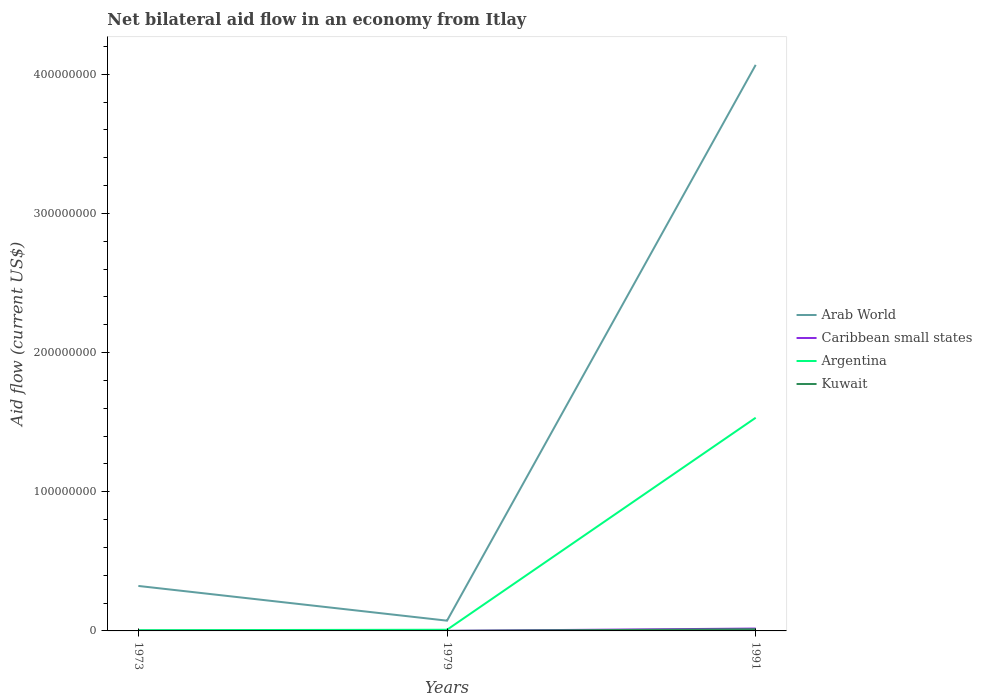How many different coloured lines are there?
Provide a succinct answer. 4. Is the number of lines equal to the number of legend labels?
Keep it short and to the point. Yes. Across all years, what is the maximum net bilateral aid flow in Argentina?
Offer a very short reply. 5.30e+05. What is the total net bilateral aid flow in Caribbean small states in the graph?
Provide a succinct answer. -1.65e+06. What is the difference between the highest and the second highest net bilateral aid flow in Kuwait?
Provide a succinct answer. 1.18e+06. How many lines are there?
Offer a very short reply. 4. How many years are there in the graph?
Your response must be concise. 3. Are the values on the major ticks of Y-axis written in scientific E-notation?
Your answer should be compact. No. Does the graph contain any zero values?
Your response must be concise. No. How many legend labels are there?
Ensure brevity in your answer.  4. What is the title of the graph?
Provide a short and direct response. Net bilateral aid flow in an economy from Itlay. Does "Virgin Islands" appear as one of the legend labels in the graph?
Provide a short and direct response. No. What is the label or title of the X-axis?
Provide a succinct answer. Years. What is the label or title of the Y-axis?
Give a very brief answer. Aid flow (current US$). What is the Aid flow (current US$) in Arab World in 1973?
Ensure brevity in your answer.  3.23e+07. What is the Aid flow (current US$) of Caribbean small states in 1973?
Offer a very short reply. 6.00e+04. What is the Aid flow (current US$) in Argentina in 1973?
Provide a short and direct response. 5.30e+05. What is the Aid flow (current US$) of Kuwait in 1973?
Give a very brief answer. 5.00e+04. What is the Aid flow (current US$) in Arab World in 1979?
Provide a short and direct response. 7.37e+06. What is the Aid flow (current US$) in Caribbean small states in 1979?
Keep it short and to the point. 5.00e+04. What is the Aid flow (current US$) of Argentina in 1979?
Your answer should be very brief. 8.40e+05. What is the Aid flow (current US$) of Arab World in 1991?
Offer a very short reply. 4.07e+08. What is the Aid flow (current US$) in Caribbean small states in 1991?
Keep it short and to the point. 1.71e+06. What is the Aid flow (current US$) in Argentina in 1991?
Your answer should be very brief. 1.53e+08. What is the Aid flow (current US$) in Kuwait in 1991?
Provide a short and direct response. 1.19e+06. Across all years, what is the maximum Aid flow (current US$) in Arab World?
Your answer should be very brief. 4.07e+08. Across all years, what is the maximum Aid flow (current US$) of Caribbean small states?
Ensure brevity in your answer.  1.71e+06. Across all years, what is the maximum Aid flow (current US$) of Argentina?
Give a very brief answer. 1.53e+08. Across all years, what is the maximum Aid flow (current US$) in Kuwait?
Your response must be concise. 1.19e+06. Across all years, what is the minimum Aid flow (current US$) in Arab World?
Give a very brief answer. 7.37e+06. Across all years, what is the minimum Aid flow (current US$) in Argentina?
Provide a short and direct response. 5.30e+05. Across all years, what is the minimum Aid flow (current US$) in Kuwait?
Your answer should be compact. 10000. What is the total Aid flow (current US$) of Arab World in the graph?
Your answer should be very brief. 4.46e+08. What is the total Aid flow (current US$) of Caribbean small states in the graph?
Provide a succinct answer. 1.82e+06. What is the total Aid flow (current US$) of Argentina in the graph?
Ensure brevity in your answer.  1.55e+08. What is the total Aid flow (current US$) in Kuwait in the graph?
Your answer should be very brief. 1.25e+06. What is the difference between the Aid flow (current US$) of Arab World in 1973 and that in 1979?
Your response must be concise. 2.50e+07. What is the difference between the Aid flow (current US$) in Caribbean small states in 1973 and that in 1979?
Provide a succinct answer. 10000. What is the difference between the Aid flow (current US$) of Argentina in 1973 and that in 1979?
Your response must be concise. -3.10e+05. What is the difference between the Aid flow (current US$) of Arab World in 1973 and that in 1991?
Provide a short and direct response. -3.74e+08. What is the difference between the Aid flow (current US$) of Caribbean small states in 1973 and that in 1991?
Provide a short and direct response. -1.65e+06. What is the difference between the Aid flow (current US$) in Argentina in 1973 and that in 1991?
Provide a short and direct response. -1.53e+08. What is the difference between the Aid flow (current US$) of Kuwait in 1973 and that in 1991?
Give a very brief answer. -1.14e+06. What is the difference between the Aid flow (current US$) of Arab World in 1979 and that in 1991?
Your answer should be compact. -3.99e+08. What is the difference between the Aid flow (current US$) in Caribbean small states in 1979 and that in 1991?
Provide a short and direct response. -1.66e+06. What is the difference between the Aid flow (current US$) in Argentina in 1979 and that in 1991?
Provide a short and direct response. -1.52e+08. What is the difference between the Aid flow (current US$) of Kuwait in 1979 and that in 1991?
Offer a very short reply. -1.18e+06. What is the difference between the Aid flow (current US$) of Arab World in 1973 and the Aid flow (current US$) of Caribbean small states in 1979?
Provide a succinct answer. 3.23e+07. What is the difference between the Aid flow (current US$) of Arab World in 1973 and the Aid flow (current US$) of Argentina in 1979?
Your answer should be compact. 3.15e+07. What is the difference between the Aid flow (current US$) in Arab World in 1973 and the Aid flow (current US$) in Kuwait in 1979?
Keep it short and to the point. 3.23e+07. What is the difference between the Aid flow (current US$) in Caribbean small states in 1973 and the Aid flow (current US$) in Argentina in 1979?
Make the answer very short. -7.80e+05. What is the difference between the Aid flow (current US$) of Argentina in 1973 and the Aid flow (current US$) of Kuwait in 1979?
Provide a short and direct response. 5.20e+05. What is the difference between the Aid flow (current US$) of Arab World in 1973 and the Aid flow (current US$) of Caribbean small states in 1991?
Provide a short and direct response. 3.06e+07. What is the difference between the Aid flow (current US$) of Arab World in 1973 and the Aid flow (current US$) of Argentina in 1991?
Your answer should be very brief. -1.21e+08. What is the difference between the Aid flow (current US$) of Arab World in 1973 and the Aid flow (current US$) of Kuwait in 1991?
Offer a terse response. 3.11e+07. What is the difference between the Aid flow (current US$) in Caribbean small states in 1973 and the Aid flow (current US$) in Argentina in 1991?
Keep it short and to the point. -1.53e+08. What is the difference between the Aid flow (current US$) of Caribbean small states in 1973 and the Aid flow (current US$) of Kuwait in 1991?
Make the answer very short. -1.13e+06. What is the difference between the Aid flow (current US$) in Argentina in 1973 and the Aid flow (current US$) in Kuwait in 1991?
Make the answer very short. -6.60e+05. What is the difference between the Aid flow (current US$) of Arab World in 1979 and the Aid flow (current US$) of Caribbean small states in 1991?
Offer a very short reply. 5.66e+06. What is the difference between the Aid flow (current US$) of Arab World in 1979 and the Aid flow (current US$) of Argentina in 1991?
Keep it short and to the point. -1.46e+08. What is the difference between the Aid flow (current US$) in Arab World in 1979 and the Aid flow (current US$) in Kuwait in 1991?
Give a very brief answer. 6.18e+06. What is the difference between the Aid flow (current US$) of Caribbean small states in 1979 and the Aid flow (current US$) of Argentina in 1991?
Your response must be concise. -1.53e+08. What is the difference between the Aid flow (current US$) in Caribbean small states in 1979 and the Aid flow (current US$) in Kuwait in 1991?
Provide a succinct answer. -1.14e+06. What is the difference between the Aid flow (current US$) in Argentina in 1979 and the Aid flow (current US$) in Kuwait in 1991?
Give a very brief answer. -3.50e+05. What is the average Aid flow (current US$) of Arab World per year?
Provide a short and direct response. 1.49e+08. What is the average Aid flow (current US$) in Caribbean small states per year?
Keep it short and to the point. 6.07e+05. What is the average Aid flow (current US$) of Argentina per year?
Provide a short and direct response. 5.15e+07. What is the average Aid flow (current US$) in Kuwait per year?
Ensure brevity in your answer.  4.17e+05. In the year 1973, what is the difference between the Aid flow (current US$) in Arab World and Aid flow (current US$) in Caribbean small states?
Offer a terse response. 3.23e+07. In the year 1973, what is the difference between the Aid flow (current US$) of Arab World and Aid flow (current US$) of Argentina?
Ensure brevity in your answer.  3.18e+07. In the year 1973, what is the difference between the Aid flow (current US$) in Arab World and Aid flow (current US$) in Kuwait?
Keep it short and to the point. 3.23e+07. In the year 1973, what is the difference between the Aid flow (current US$) of Caribbean small states and Aid flow (current US$) of Argentina?
Ensure brevity in your answer.  -4.70e+05. In the year 1973, what is the difference between the Aid flow (current US$) of Caribbean small states and Aid flow (current US$) of Kuwait?
Offer a very short reply. 10000. In the year 1973, what is the difference between the Aid flow (current US$) of Argentina and Aid flow (current US$) of Kuwait?
Your answer should be compact. 4.80e+05. In the year 1979, what is the difference between the Aid flow (current US$) in Arab World and Aid flow (current US$) in Caribbean small states?
Offer a very short reply. 7.32e+06. In the year 1979, what is the difference between the Aid flow (current US$) of Arab World and Aid flow (current US$) of Argentina?
Your response must be concise. 6.53e+06. In the year 1979, what is the difference between the Aid flow (current US$) in Arab World and Aid flow (current US$) in Kuwait?
Provide a succinct answer. 7.36e+06. In the year 1979, what is the difference between the Aid flow (current US$) in Caribbean small states and Aid flow (current US$) in Argentina?
Your answer should be very brief. -7.90e+05. In the year 1979, what is the difference between the Aid flow (current US$) in Caribbean small states and Aid flow (current US$) in Kuwait?
Make the answer very short. 4.00e+04. In the year 1979, what is the difference between the Aid flow (current US$) of Argentina and Aid flow (current US$) of Kuwait?
Provide a short and direct response. 8.30e+05. In the year 1991, what is the difference between the Aid flow (current US$) of Arab World and Aid flow (current US$) of Caribbean small states?
Make the answer very short. 4.05e+08. In the year 1991, what is the difference between the Aid flow (current US$) in Arab World and Aid flow (current US$) in Argentina?
Your answer should be compact. 2.54e+08. In the year 1991, what is the difference between the Aid flow (current US$) of Arab World and Aid flow (current US$) of Kuwait?
Your answer should be very brief. 4.06e+08. In the year 1991, what is the difference between the Aid flow (current US$) of Caribbean small states and Aid flow (current US$) of Argentina?
Give a very brief answer. -1.51e+08. In the year 1991, what is the difference between the Aid flow (current US$) of Caribbean small states and Aid flow (current US$) of Kuwait?
Your response must be concise. 5.20e+05. In the year 1991, what is the difference between the Aid flow (current US$) in Argentina and Aid flow (current US$) in Kuwait?
Provide a short and direct response. 1.52e+08. What is the ratio of the Aid flow (current US$) in Arab World in 1973 to that in 1979?
Keep it short and to the point. 4.39. What is the ratio of the Aid flow (current US$) in Caribbean small states in 1973 to that in 1979?
Provide a succinct answer. 1.2. What is the ratio of the Aid flow (current US$) of Argentina in 1973 to that in 1979?
Offer a terse response. 0.63. What is the ratio of the Aid flow (current US$) of Arab World in 1973 to that in 1991?
Your answer should be compact. 0.08. What is the ratio of the Aid flow (current US$) in Caribbean small states in 1973 to that in 1991?
Your answer should be compact. 0.04. What is the ratio of the Aid flow (current US$) of Argentina in 1973 to that in 1991?
Provide a short and direct response. 0. What is the ratio of the Aid flow (current US$) of Kuwait in 1973 to that in 1991?
Offer a very short reply. 0.04. What is the ratio of the Aid flow (current US$) of Arab World in 1979 to that in 1991?
Offer a terse response. 0.02. What is the ratio of the Aid flow (current US$) of Caribbean small states in 1979 to that in 1991?
Provide a short and direct response. 0.03. What is the ratio of the Aid flow (current US$) of Argentina in 1979 to that in 1991?
Ensure brevity in your answer.  0.01. What is the ratio of the Aid flow (current US$) in Kuwait in 1979 to that in 1991?
Provide a short and direct response. 0.01. What is the difference between the highest and the second highest Aid flow (current US$) of Arab World?
Your answer should be compact. 3.74e+08. What is the difference between the highest and the second highest Aid flow (current US$) in Caribbean small states?
Your answer should be compact. 1.65e+06. What is the difference between the highest and the second highest Aid flow (current US$) in Argentina?
Make the answer very short. 1.52e+08. What is the difference between the highest and the second highest Aid flow (current US$) in Kuwait?
Provide a succinct answer. 1.14e+06. What is the difference between the highest and the lowest Aid flow (current US$) of Arab World?
Provide a succinct answer. 3.99e+08. What is the difference between the highest and the lowest Aid flow (current US$) in Caribbean small states?
Make the answer very short. 1.66e+06. What is the difference between the highest and the lowest Aid flow (current US$) in Argentina?
Provide a short and direct response. 1.53e+08. What is the difference between the highest and the lowest Aid flow (current US$) of Kuwait?
Ensure brevity in your answer.  1.18e+06. 